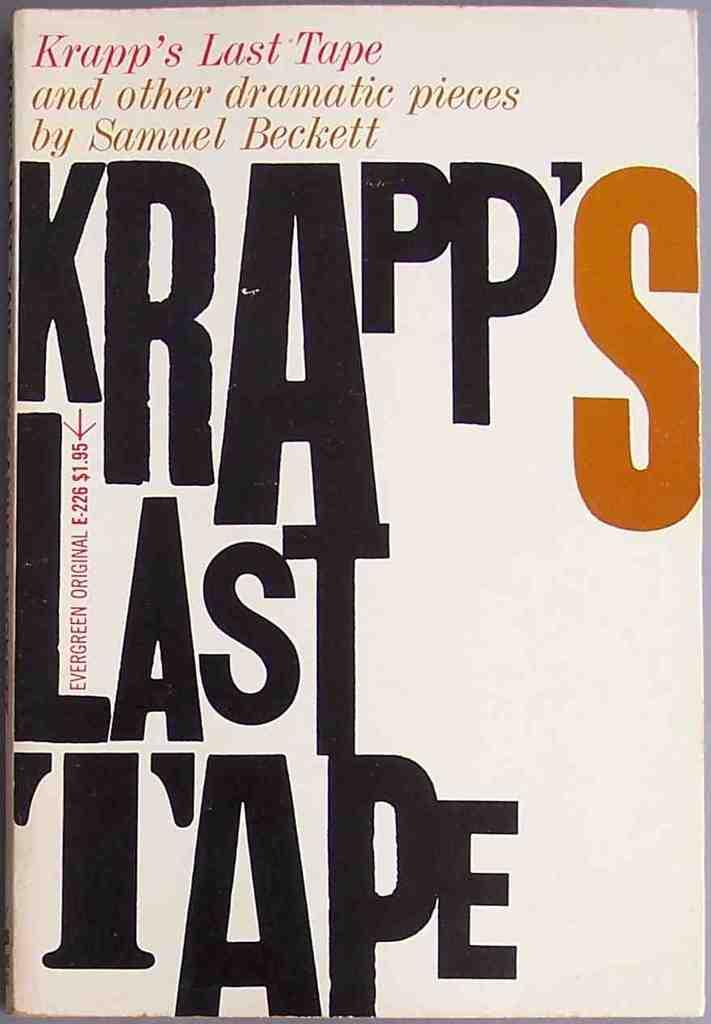Who wrote, "krapp's last tape"?
Offer a terse response. Samuel beckett. What is the price of this book?
Your answer should be very brief. 1.95. 